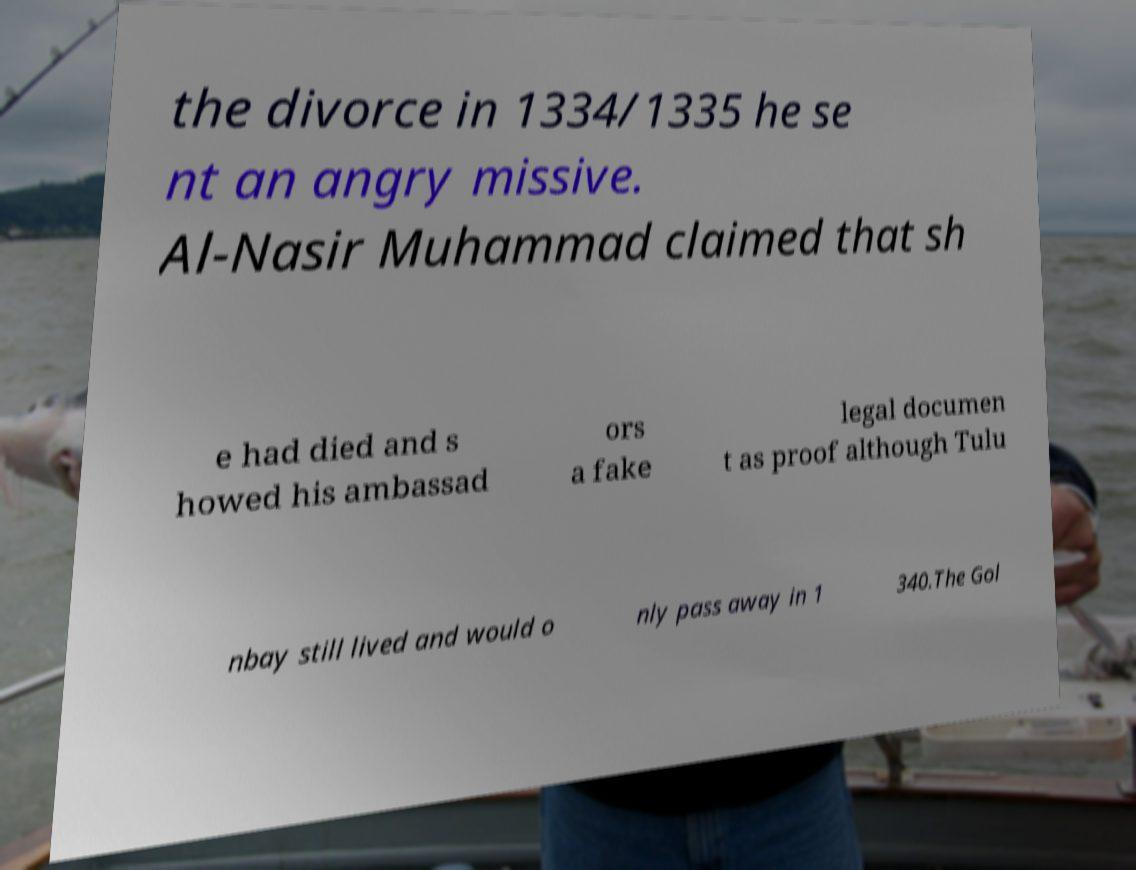Please read and relay the text visible in this image. What does it say? the divorce in 1334/1335 he se nt an angry missive. Al-Nasir Muhammad claimed that sh e had died and s howed his ambassad ors a fake legal documen t as proof although Tulu nbay still lived and would o nly pass away in 1 340.The Gol 